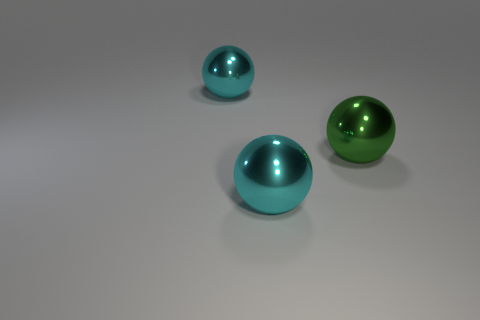Subtract all big cyan spheres. How many spheres are left? 1 Add 1 large green metallic spheres. How many objects exist? 4 Subtract all blue cylinders. How many cyan spheres are left? 2 Subtract all green balls. How many balls are left? 2 Subtract 0 purple cylinders. How many objects are left? 3 Subtract all brown spheres. Subtract all green cubes. How many spheres are left? 3 Subtract all big things. Subtract all tiny yellow matte blocks. How many objects are left? 0 Add 2 cyan metallic objects. How many cyan metallic objects are left? 4 Add 3 large green objects. How many large green objects exist? 4 